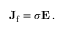Convert formula to latex. <formula><loc_0><loc_0><loc_500><loc_500>J _ { f } = \sigma E \, .</formula> 